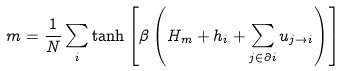<formula> <loc_0><loc_0><loc_500><loc_500>m = \frac { 1 } { N } \sum _ { i } \tanh \left [ \beta \left ( H _ { m } + h _ { i } + \sum _ { j \in \partial i } u _ { j \to i } \right ) \right ]</formula> 